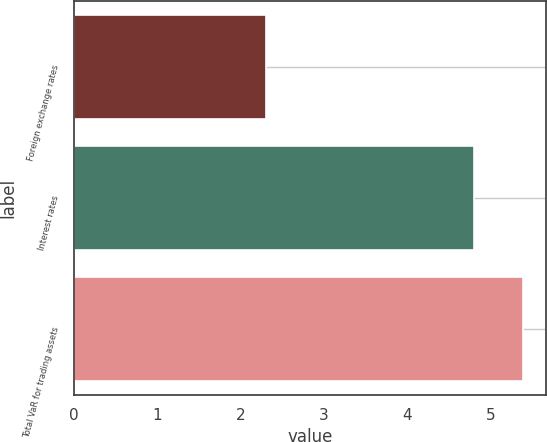<chart> <loc_0><loc_0><loc_500><loc_500><bar_chart><fcel>Foreign exchange rates<fcel>Interest rates<fcel>Total VaR for trading assets<nl><fcel>2.3<fcel>4.8<fcel>5.4<nl></chart> 